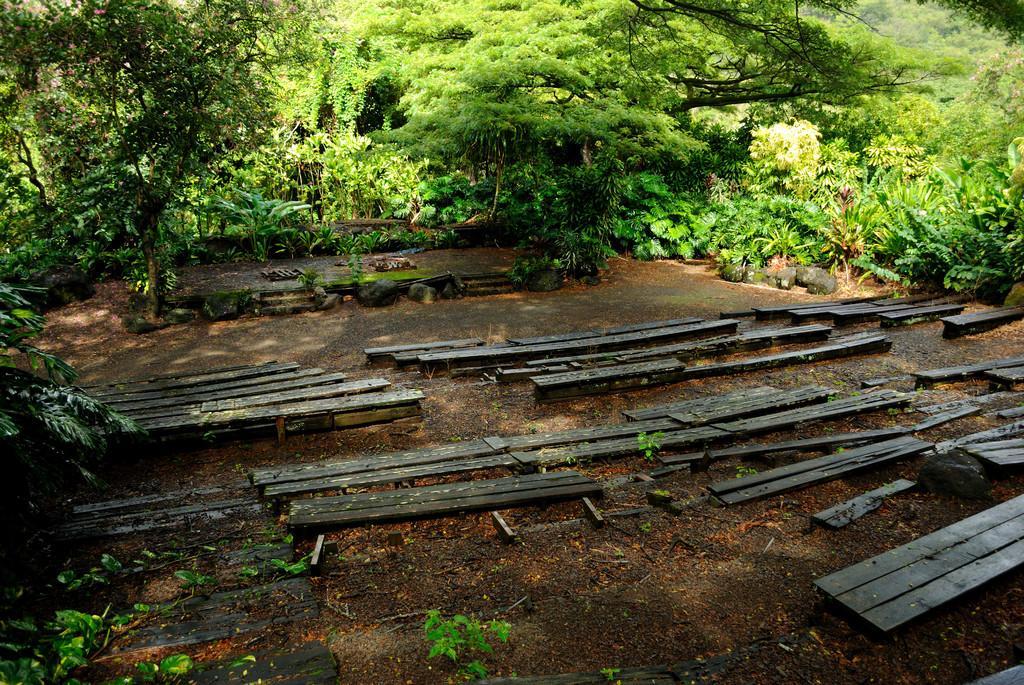How would you summarize this image in a sentence or two? In this picture we can see there are wooden benches on the path and in front of the wooden benches there are plants and trees. 